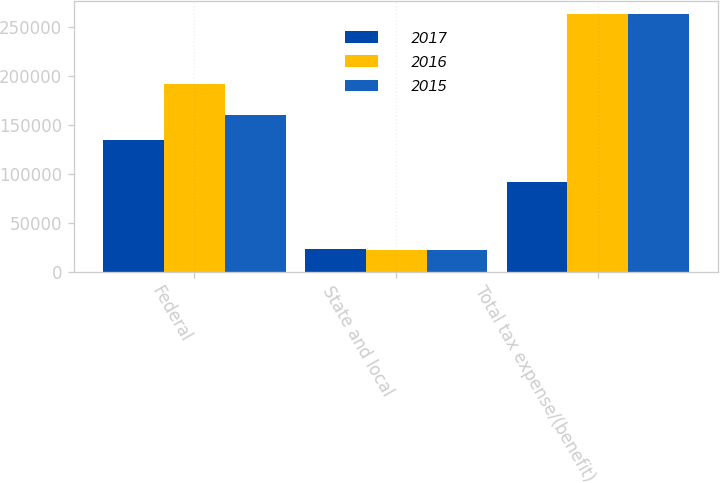<chart> <loc_0><loc_0><loc_500><loc_500><stacked_bar_chart><ecel><fcel>Federal<fcel>State and local<fcel>Total tax expense/(benefit)<nl><fcel>2017<fcel>134284<fcel>23456<fcel>91024<nl><fcel>2016<fcel>191422<fcel>21871<fcel>263707<nl><fcel>2015<fcel>160235<fcel>22306<fcel>262968<nl></chart> 